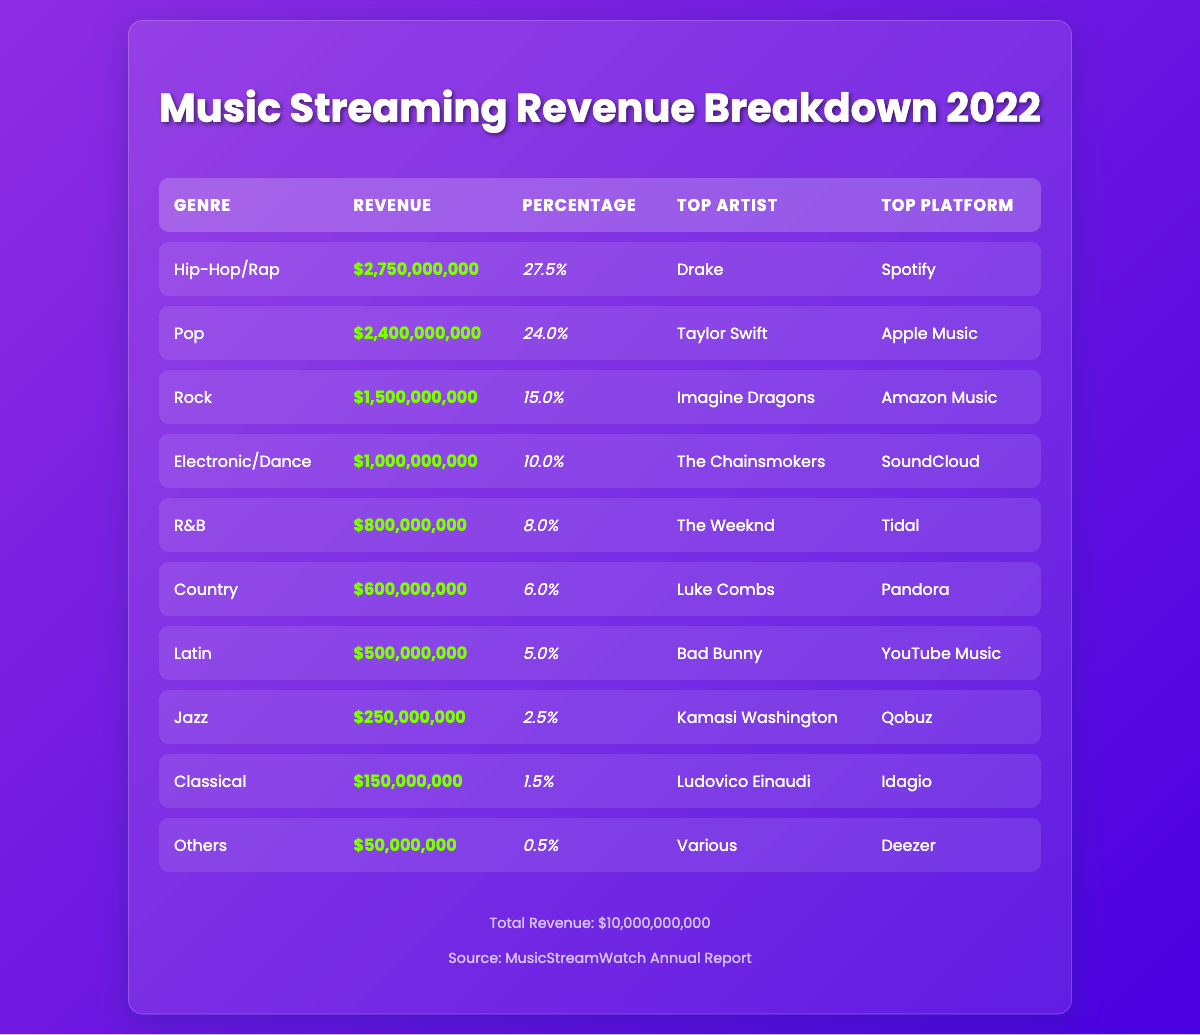What was the revenue for the Pop genre in 2022? According to the table, the revenue listed for the Pop genre is $2,400,000,000.
Answer: $2,400,000,000 Which genre had the highest revenue percentage? The Hip-Hop/Rap genre has the highest percentage of revenue at 27.5%.
Answer: 27.5% Is the top artist in the R&B genre the same as in the Rock genre? No, the top artist in R&B is The Weeknd, while the top artist in Rock is Imagine Dragons, thus they are different artists.
Answer: No What is the total revenue generated by the Electronic/Dance and Latin genres combined? The revenue for Electronic/Dance is $1,000,000,000, and for Latin, it is $500,000,000. Adding these together: $1,000,000,000 + $500,000,000 = $1,500,000,000.
Answer: $1,500,000,000 If you add the revenue of Jazz and Classical genres, how does it compare to the revenue of R&B? The revenue for Jazz is $250,000,000, and for Classical it is $150,000,000. Together they add up to $250,000,000 + $150,000,000 = $400,000,000, which is less than the R&B genre revenue of $800,000,000.
Answer: Less than R&B Which platform is the top for the Country genre? The top platform listed for the Country genre is Pandora.
Answer: Pandora How much does the "Others" genre contribute to the total revenue? The "Others" genre contributes $50,000,000, which is calculated as a very small fraction compared to the total revenue.
Answer: $50,000,000 What is the difference in revenue between the top two genres, Hip-Hop/Rap and Pop? The revenue for Hip-Hop/Rap is $2,750,000,000, and for Pop, it is $2,400,000,000. The difference is $2,750,000,000 - $2,400,000,000 = $350,000,000.
Answer: $350,000,000 